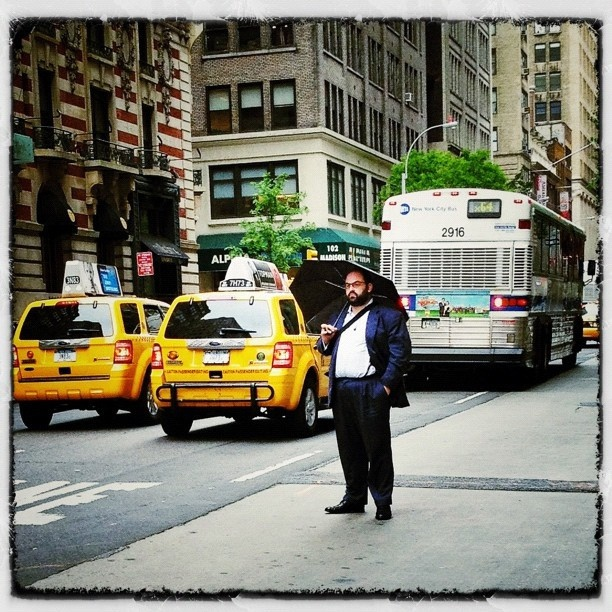Describe the objects in this image and their specific colors. I can see bus in lightgray, black, darkgray, and gray tones, car in lightgray, black, ivory, gold, and orange tones, car in lightgray, black, orange, red, and maroon tones, people in lightgray, black, white, navy, and gray tones, and umbrella in lightgray, black, gray, and maroon tones in this image. 